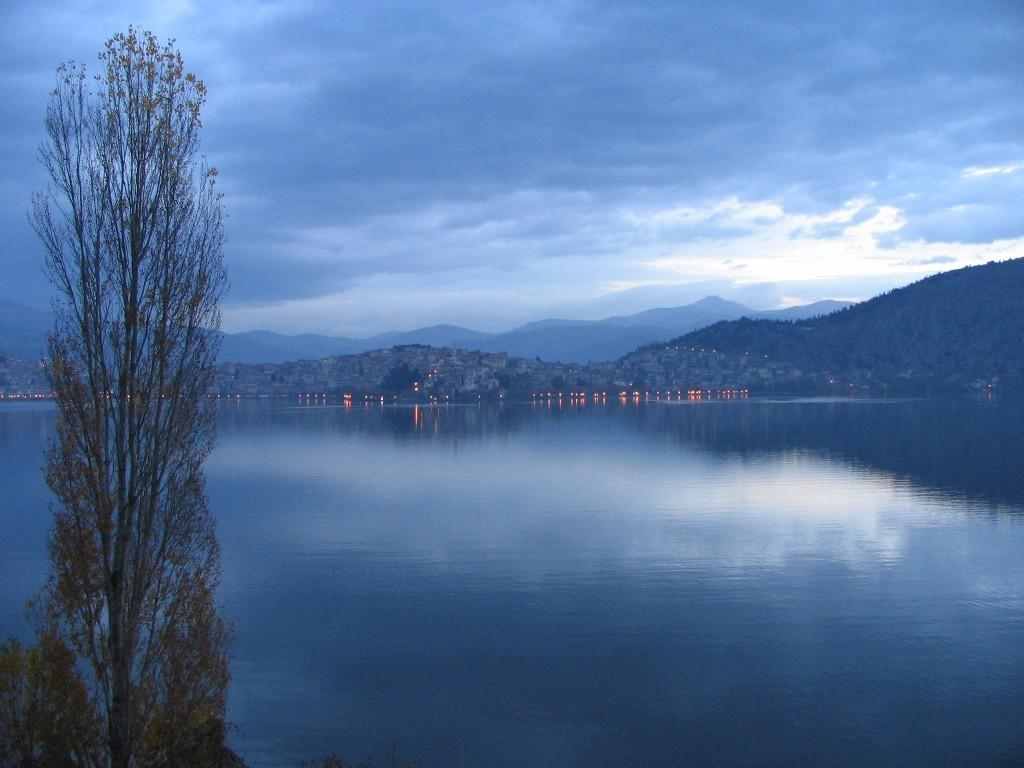What type of vegetation is present in the image? There is a tree in the image. What natural element can be seen besides the tree? There is water visible in the image. What geographical feature is present in the background of the image? There are mountains in the image. What is the condition of the sky in the image? The sky is cloudy in the image. Can you see any fairies flying around the tree in the image? There are no fairies present in the image; it features a tree, water, mountains, and a cloudy sky. What type of print is visible on the water in the image? There is no print visible on the water in the image; it is a natural body of water. 